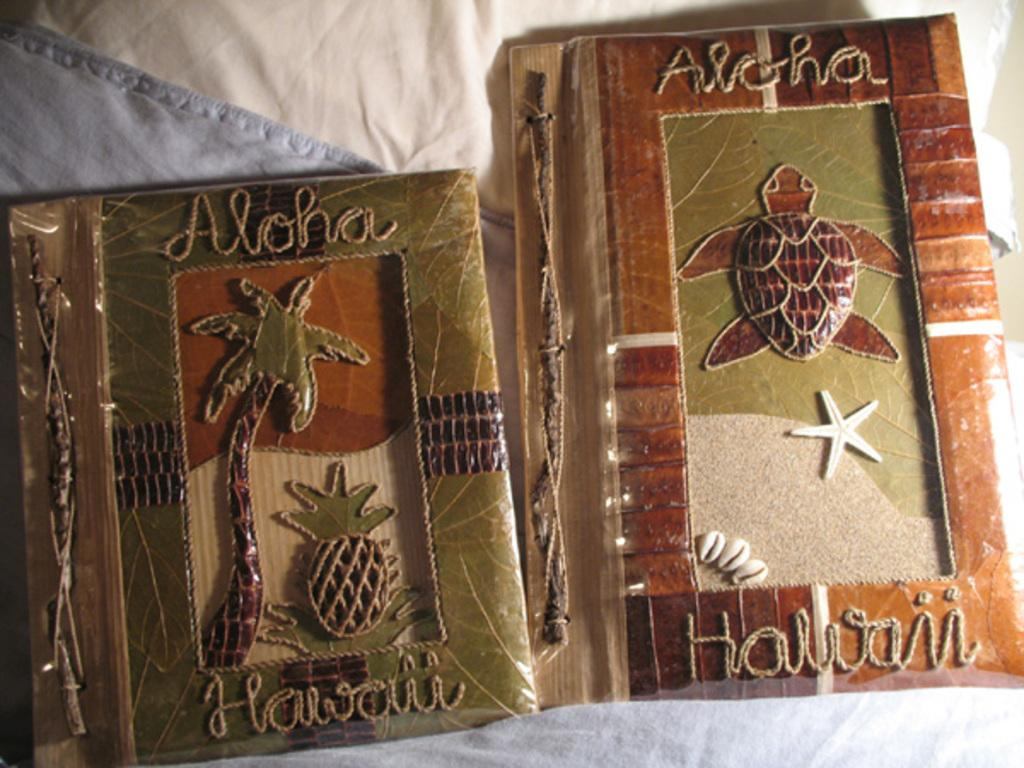<image>
Write a terse but informative summary of the picture. Two Aloha Hawaii books with a coconut tree and a turtle on their covers are on a bed. 